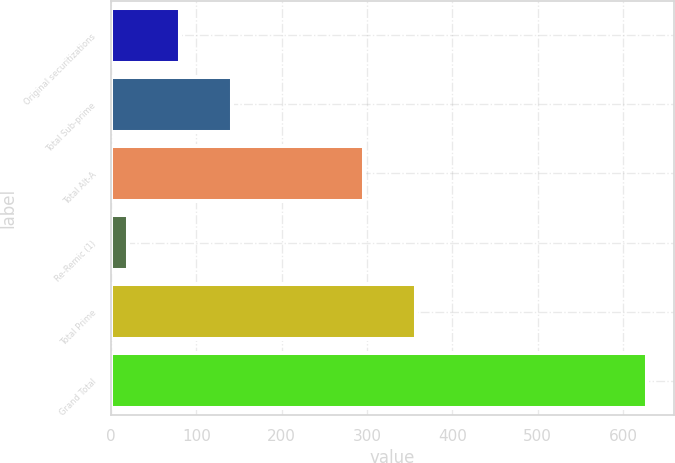Convert chart. <chart><loc_0><loc_0><loc_500><loc_500><bar_chart><fcel>Original securitizations<fcel>Total Sub-prime<fcel>Total Alt-A<fcel>Re-Remic (1)<fcel>Total Prime<fcel>Grand Total<nl><fcel>80.8<fcel>141.6<fcel>296<fcel>20<fcel>356.8<fcel>628<nl></chart> 